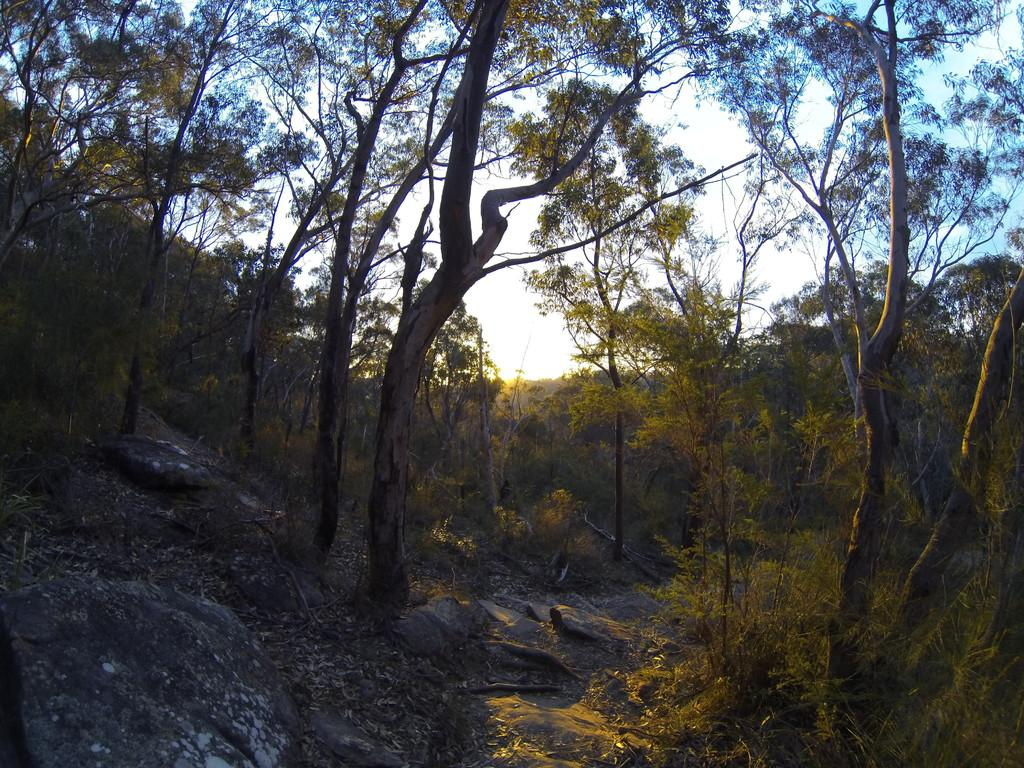What type of natural elements can be seen in the image? There are rocks and trees in the image. What is present on the ground in the image? There are leaves on the ground in the image. Is there a designated route for walking in the image? Yes, there is a path in the image. What can be seen in the background of the image? The sky is visible in the background of the image. What type of behavior can be observed in the coil of the ray in the image? There is no ray, behavior, or coil present in the image. 